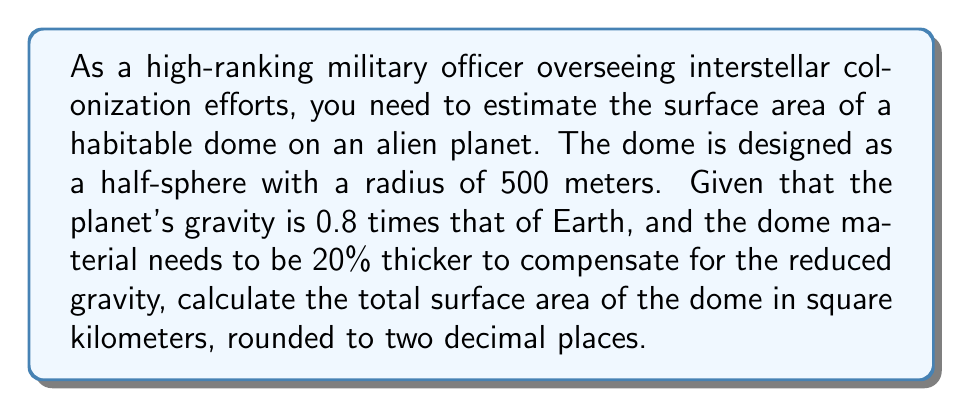Teach me how to tackle this problem. To solve this problem, we'll follow these steps:

1. Calculate the surface area of a half-sphere (dome):
   The formula for the surface area of a sphere is $A = 4\pi r^2$, where $r$ is the radius.
   For a half-sphere, we use half of this formula plus the area of the circular base:
   $$A_{dome} = 2\pi r^2 + \pi r^2 = 3\pi r^2$$

2. Substitute the given radius:
   $$A_{dome} = 3\pi (500\text{ m})^2 = 3\pi \cdot 250,000\text{ m}^2$$

3. Calculate the result:
   $$A_{dome} = 2,356,194.49\text{ m}^2$$

4. Adjust for the increased thickness due to reduced gravity:
   The surface area needs to be increased by 20%:
   $$A_{adjusted} = A_{dome} \cdot 1.20 = 2,356,194.49\text{ m}^2 \cdot 1.20 = 2,827,433.39\text{ m}^2$$

5. Convert to square kilometers:
   $$A_{km^2} = 2,827,433.39\text{ m}^2 \cdot \frac{1\text{ km}^2}{1,000,000\text{ m}^2} = 2.82743339\text{ km}^2$$

6. Round to two decimal places:
   $$A_{final} = 2.83\text{ km}^2$$

[asy]
import geometry;

size(200);
pair O = (0,0);
real r = 5;
path c = circle(O, r);
draw(c);
draw((-r,0)--(r,0));
draw(O--(0,r), dashed);
label("r", (r/2,r/2), NE);
label("500 m", (0,-r-0.5), S);
[/asy]
Answer: The total surface area of the habitable dome on the alien planet is approximately $2.83\text{ km}^2$. 